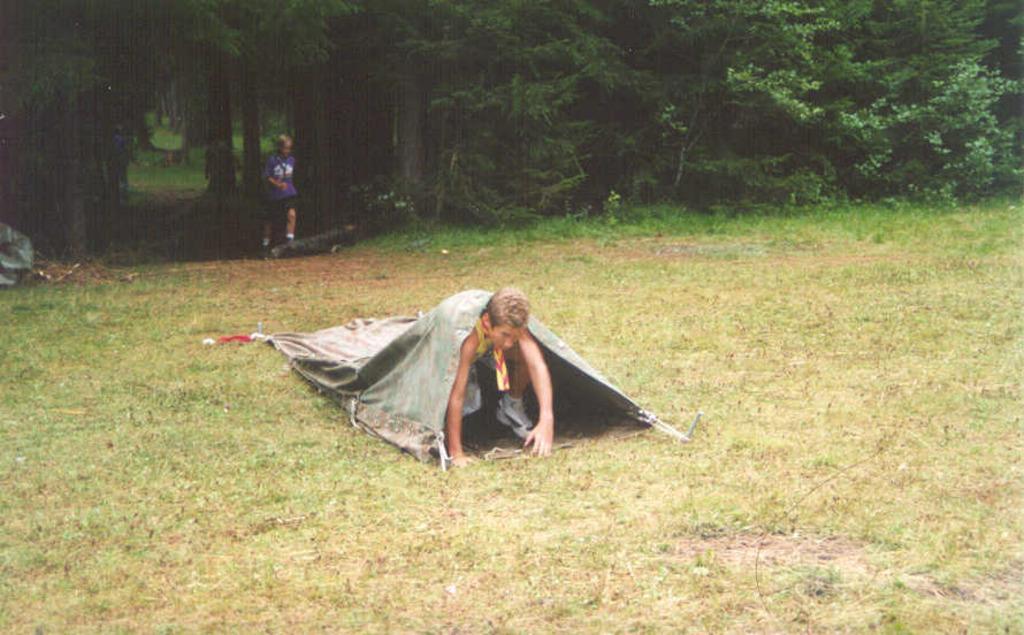In one or two sentences, can you explain what this image depicts? In this image I can see in the middle a person is trying to come out from this cloth. At the back side there are trees and a person is there. 